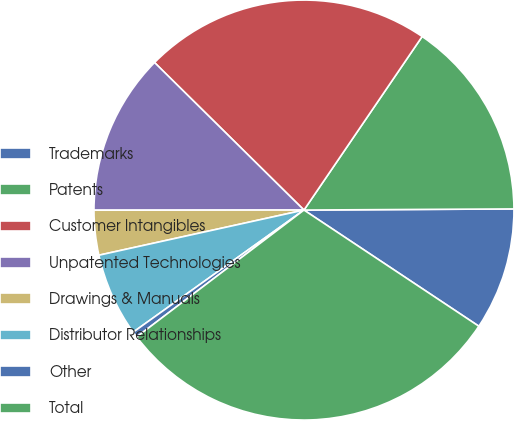<chart> <loc_0><loc_0><loc_500><loc_500><pie_chart><fcel>Trademarks<fcel>Patents<fcel>Customer Intangibles<fcel>Unpatented Technologies<fcel>Drawings & Manuals<fcel>Distributor Relationships<fcel>Other<fcel>Total<nl><fcel>9.42%<fcel>15.4%<fcel>22.12%<fcel>12.41%<fcel>3.44%<fcel>6.43%<fcel>0.45%<fcel>30.34%<nl></chart> 